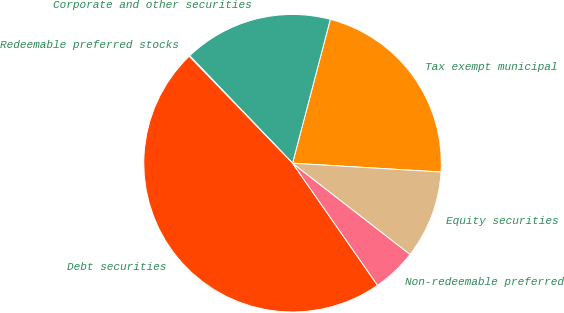Convert chart to OTSL. <chart><loc_0><loc_0><loc_500><loc_500><pie_chart><fcel>Tax exempt municipal<fcel>Corporate and other securities<fcel>Redeemable preferred stocks<fcel>Debt securities<fcel>Non-redeemable preferred<fcel>Equity securities<nl><fcel>21.86%<fcel>16.24%<fcel>0.08%<fcel>47.45%<fcel>4.82%<fcel>9.56%<nl></chart> 